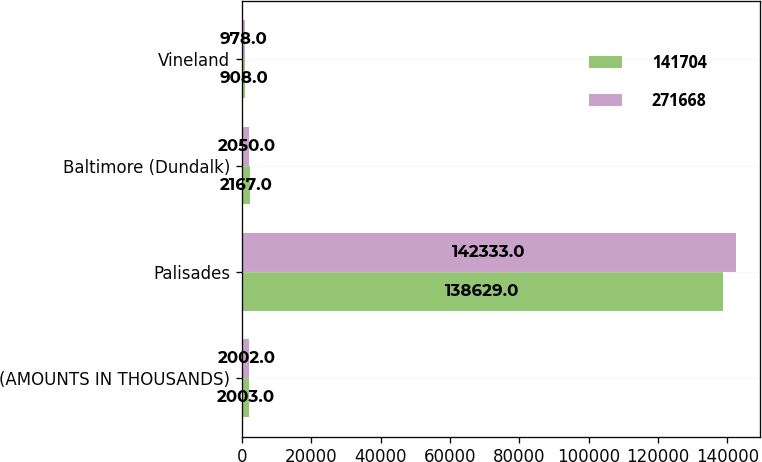Convert chart to OTSL. <chart><loc_0><loc_0><loc_500><loc_500><stacked_bar_chart><ecel><fcel>(AMOUNTS IN THOUSANDS)<fcel>Palisades<fcel>Baltimore (Dundalk)<fcel>Vineland<nl><fcel>141704<fcel>2003<fcel>138629<fcel>2167<fcel>908<nl><fcel>271668<fcel>2002<fcel>142333<fcel>2050<fcel>978<nl></chart> 